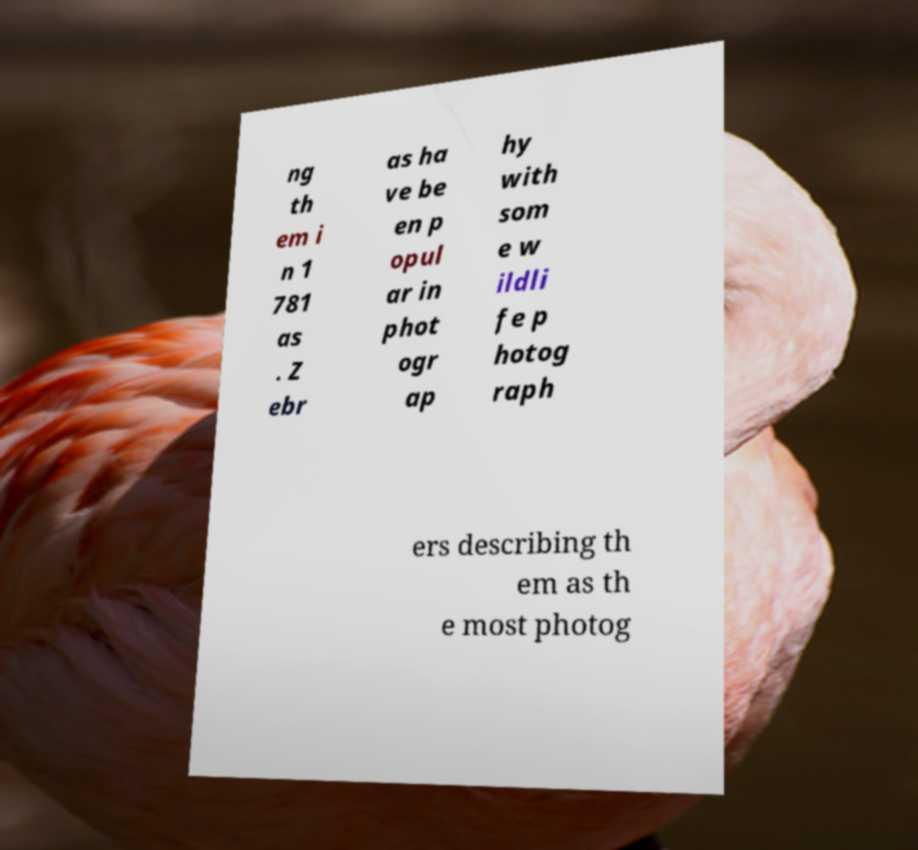There's text embedded in this image that I need extracted. Can you transcribe it verbatim? ng th em i n 1 781 as . Z ebr as ha ve be en p opul ar in phot ogr ap hy with som e w ildli fe p hotog raph ers describing th em as th e most photog 